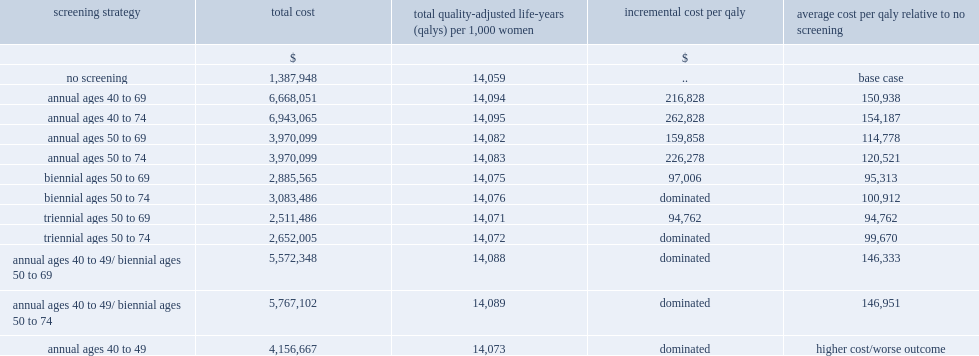For the cost-effectiveness analysis, which screening strategies for women had lower incremental ratios? strategies in which screening continued to age 74 or those aged 50 to 69? Annual ages 50 to 69. Which screening strategy has the lowest incremental ratio? Triennial ages 50 to 69. 